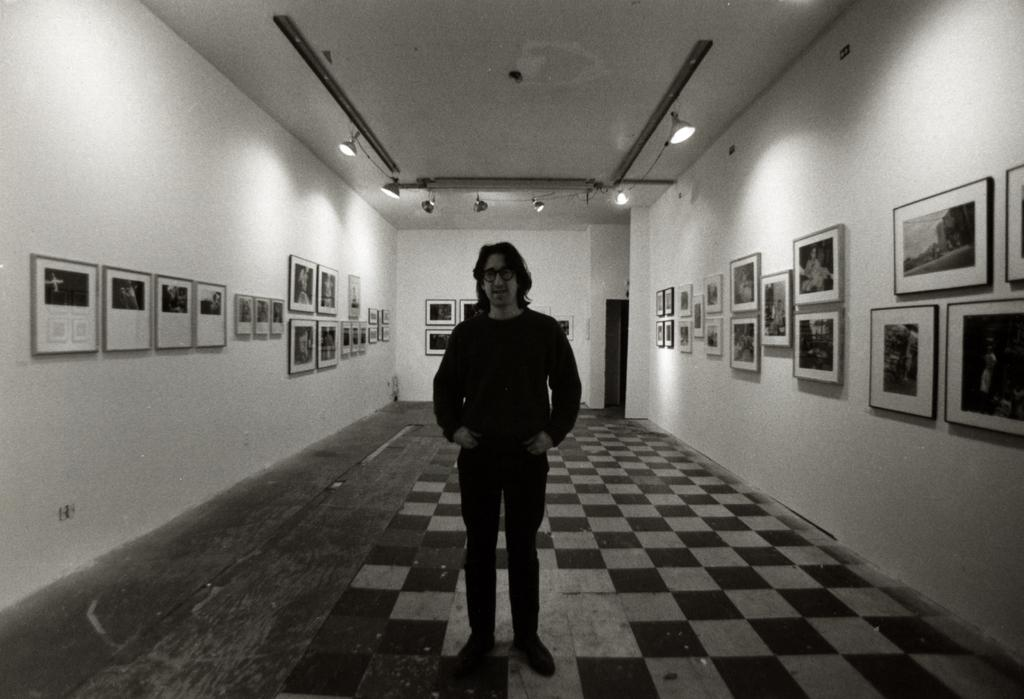What is the main subject in the image? There is a person standing in the image. Where are the photo frames located in the image? There are photo frames on both the right and left sides of the image. What can be seen in the background of the image? There is a wall in the background of the image. What is illuminating the scene in the image? There are lights visible in the image. Can you tell me how many bikes are parked next to the person in the image? There are no bikes present in the image. What type of box is being used to store the photo frames in the image? There are no boxes visible in the image; the photo frames are hanging on the walls. 